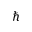<formula> <loc_0><loc_0><loc_500><loc_500>\hbar</formula> 